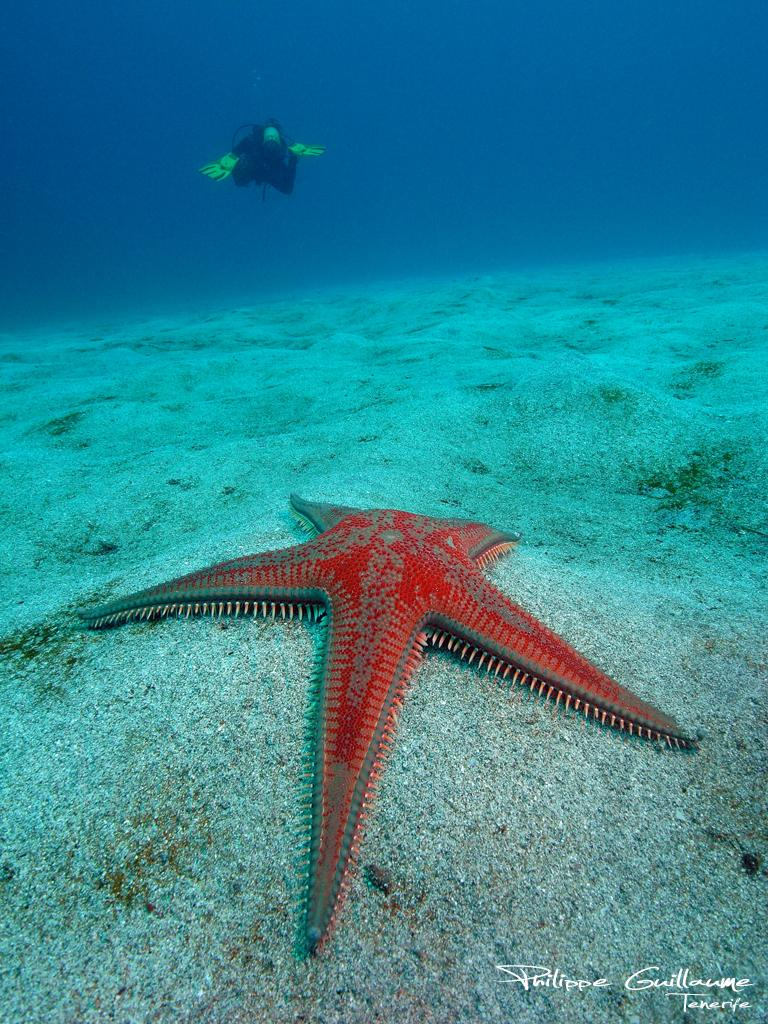What type of environment is depicted in the image? The image is an underwater scene. What activity is the human in the image engaged in? The human is swimming in the image. What can be seen at the bottom of the underwater scene? The ground is visible in the image. What marine creature is present in the image? There is a starfish in the image. What is the color of the starfish? The starfish is orange in color. Can you tell me how many goldfish are swimming near the starfish in the image? There are no goldfish present in the image; it is an underwater scene with a human swimming and a starfish. Is there a chessboard visible in the image? There is no chessboard present in the image; it is an underwater scene with a human swimming and a starfish. 